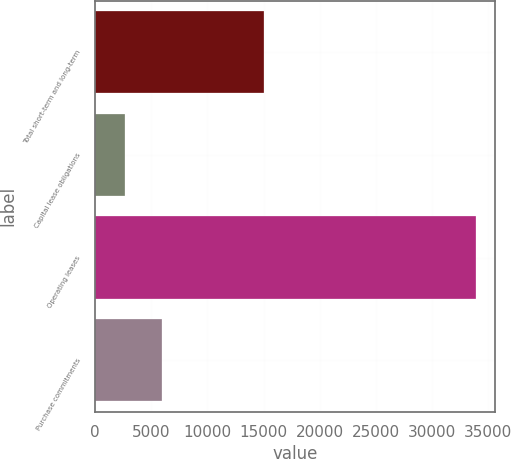Convert chart to OTSL. <chart><loc_0><loc_0><loc_500><loc_500><bar_chart><fcel>Total short-term and long-term<fcel>Capital lease obligations<fcel>Operating leases<fcel>Purchase commitments<nl><fcel>15000<fcel>2654<fcel>33888<fcel>5960<nl></chart> 